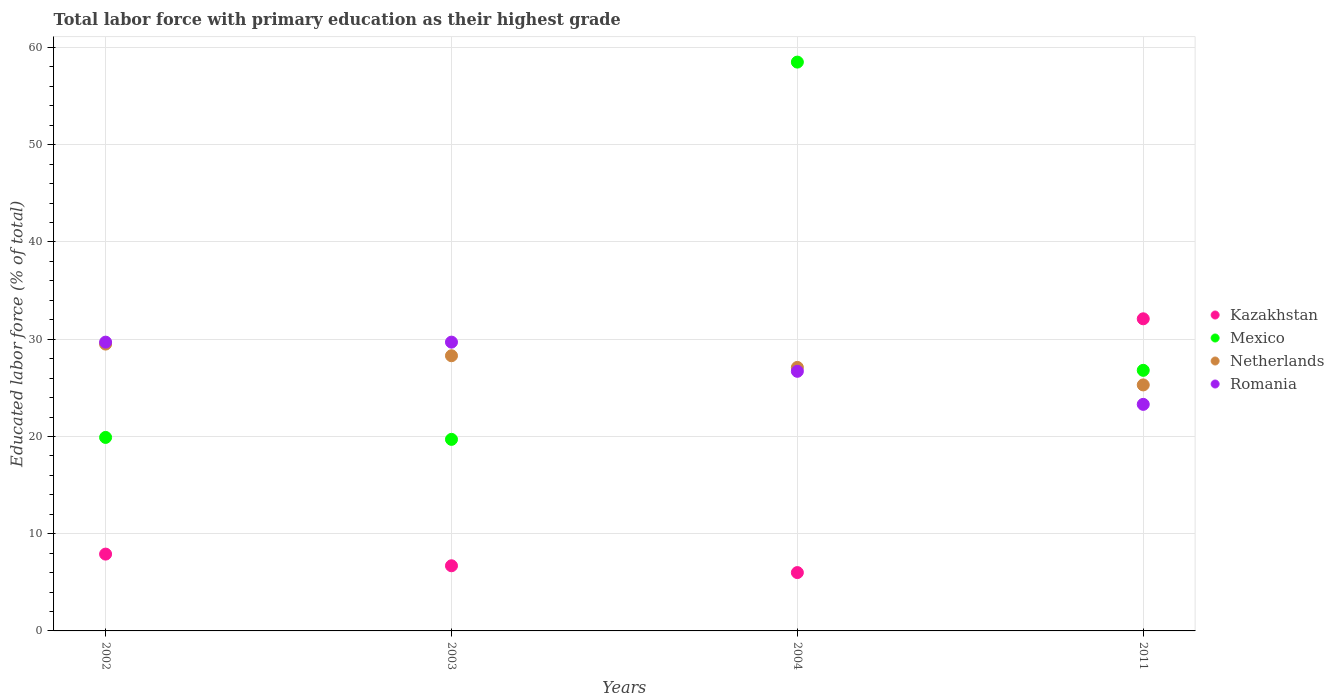How many different coloured dotlines are there?
Your response must be concise. 4. What is the percentage of total labor force with primary education in Romania in 2003?
Make the answer very short. 29.7. Across all years, what is the maximum percentage of total labor force with primary education in Netherlands?
Your answer should be compact. 29.5. Across all years, what is the minimum percentage of total labor force with primary education in Mexico?
Make the answer very short. 19.7. In which year was the percentage of total labor force with primary education in Romania maximum?
Your response must be concise. 2002. What is the total percentage of total labor force with primary education in Romania in the graph?
Ensure brevity in your answer.  109.4. What is the difference between the percentage of total labor force with primary education in Romania in 2002 and that in 2011?
Offer a terse response. 6.4. What is the difference between the percentage of total labor force with primary education in Mexico in 2004 and the percentage of total labor force with primary education in Netherlands in 2003?
Provide a short and direct response. 30.2. What is the average percentage of total labor force with primary education in Mexico per year?
Your response must be concise. 31.22. In the year 2002, what is the difference between the percentage of total labor force with primary education in Netherlands and percentage of total labor force with primary education in Kazakhstan?
Give a very brief answer. 21.6. What is the ratio of the percentage of total labor force with primary education in Romania in 2002 to that in 2003?
Make the answer very short. 1. Is the percentage of total labor force with primary education in Romania in 2002 less than that in 2011?
Give a very brief answer. No. What is the difference between the highest and the second highest percentage of total labor force with primary education in Kazakhstan?
Your answer should be compact. 24.2. What is the difference between the highest and the lowest percentage of total labor force with primary education in Mexico?
Provide a succinct answer. 38.8. In how many years, is the percentage of total labor force with primary education in Mexico greater than the average percentage of total labor force with primary education in Mexico taken over all years?
Provide a succinct answer. 1. Is it the case that in every year, the sum of the percentage of total labor force with primary education in Netherlands and percentage of total labor force with primary education in Romania  is greater than the percentage of total labor force with primary education in Mexico?
Give a very brief answer. No. Is the percentage of total labor force with primary education in Kazakhstan strictly greater than the percentage of total labor force with primary education in Netherlands over the years?
Your answer should be compact. No. Is the percentage of total labor force with primary education in Romania strictly less than the percentage of total labor force with primary education in Mexico over the years?
Your answer should be compact. No. How many years are there in the graph?
Provide a short and direct response. 4. Are the values on the major ticks of Y-axis written in scientific E-notation?
Give a very brief answer. No. Does the graph contain any zero values?
Offer a terse response. No. How many legend labels are there?
Provide a succinct answer. 4. What is the title of the graph?
Your answer should be very brief. Total labor force with primary education as their highest grade. What is the label or title of the Y-axis?
Offer a terse response. Educated labor force (% of total). What is the Educated labor force (% of total) in Kazakhstan in 2002?
Offer a terse response. 7.9. What is the Educated labor force (% of total) in Mexico in 2002?
Give a very brief answer. 19.9. What is the Educated labor force (% of total) in Netherlands in 2002?
Give a very brief answer. 29.5. What is the Educated labor force (% of total) in Romania in 2002?
Give a very brief answer. 29.7. What is the Educated labor force (% of total) of Kazakhstan in 2003?
Give a very brief answer. 6.7. What is the Educated labor force (% of total) in Mexico in 2003?
Provide a short and direct response. 19.7. What is the Educated labor force (% of total) of Netherlands in 2003?
Make the answer very short. 28.3. What is the Educated labor force (% of total) of Romania in 2003?
Offer a very short reply. 29.7. What is the Educated labor force (% of total) in Kazakhstan in 2004?
Make the answer very short. 6. What is the Educated labor force (% of total) in Mexico in 2004?
Your answer should be compact. 58.5. What is the Educated labor force (% of total) of Netherlands in 2004?
Your answer should be very brief. 27.1. What is the Educated labor force (% of total) of Romania in 2004?
Make the answer very short. 26.7. What is the Educated labor force (% of total) of Kazakhstan in 2011?
Give a very brief answer. 32.1. What is the Educated labor force (% of total) in Mexico in 2011?
Give a very brief answer. 26.8. What is the Educated labor force (% of total) of Netherlands in 2011?
Offer a terse response. 25.3. What is the Educated labor force (% of total) in Romania in 2011?
Provide a short and direct response. 23.3. Across all years, what is the maximum Educated labor force (% of total) of Kazakhstan?
Make the answer very short. 32.1. Across all years, what is the maximum Educated labor force (% of total) in Mexico?
Your answer should be compact. 58.5. Across all years, what is the maximum Educated labor force (% of total) in Netherlands?
Keep it short and to the point. 29.5. Across all years, what is the maximum Educated labor force (% of total) in Romania?
Offer a very short reply. 29.7. Across all years, what is the minimum Educated labor force (% of total) in Mexico?
Keep it short and to the point. 19.7. Across all years, what is the minimum Educated labor force (% of total) of Netherlands?
Keep it short and to the point. 25.3. Across all years, what is the minimum Educated labor force (% of total) in Romania?
Your answer should be very brief. 23.3. What is the total Educated labor force (% of total) of Kazakhstan in the graph?
Offer a very short reply. 52.7. What is the total Educated labor force (% of total) in Mexico in the graph?
Give a very brief answer. 124.9. What is the total Educated labor force (% of total) of Netherlands in the graph?
Provide a short and direct response. 110.2. What is the total Educated labor force (% of total) of Romania in the graph?
Offer a terse response. 109.4. What is the difference between the Educated labor force (% of total) of Kazakhstan in 2002 and that in 2003?
Provide a short and direct response. 1.2. What is the difference between the Educated labor force (% of total) of Mexico in 2002 and that in 2004?
Your answer should be compact. -38.6. What is the difference between the Educated labor force (% of total) of Netherlands in 2002 and that in 2004?
Your response must be concise. 2.4. What is the difference between the Educated labor force (% of total) in Kazakhstan in 2002 and that in 2011?
Offer a terse response. -24.2. What is the difference between the Educated labor force (% of total) in Netherlands in 2002 and that in 2011?
Keep it short and to the point. 4.2. What is the difference between the Educated labor force (% of total) in Romania in 2002 and that in 2011?
Keep it short and to the point. 6.4. What is the difference between the Educated labor force (% of total) in Kazakhstan in 2003 and that in 2004?
Keep it short and to the point. 0.7. What is the difference between the Educated labor force (% of total) in Mexico in 2003 and that in 2004?
Your answer should be very brief. -38.8. What is the difference between the Educated labor force (% of total) in Kazakhstan in 2003 and that in 2011?
Keep it short and to the point. -25.4. What is the difference between the Educated labor force (% of total) in Kazakhstan in 2004 and that in 2011?
Provide a short and direct response. -26.1. What is the difference between the Educated labor force (% of total) of Mexico in 2004 and that in 2011?
Provide a short and direct response. 31.7. What is the difference between the Educated labor force (% of total) of Netherlands in 2004 and that in 2011?
Your answer should be compact. 1.8. What is the difference between the Educated labor force (% of total) of Kazakhstan in 2002 and the Educated labor force (% of total) of Mexico in 2003?
Your answer should be compact. -11.8. What is the difference between the Educated labor force (% of total) in Kazakhstan in 2002 and the Educated labor force (% of total) in Netherlands in 2003?
Offer a very short reply. -20.4. What is the difference between the Educated labor force (% of total) in Kazakhstan in 2002 and the Educated labor force (% of total) in Romania in 2003?
Ensure brevity in your answer.  -21.8. What is the difference between the Educated labor force (% of total) in Mexico in 2002 and the Educated labor force (% of total) in Netherlands in 2003?
Your answer should be very brief. -8.4. What is the difference between the Educated labor force (% of total) in Netherlands in 2002 and the Educated labor force (% of total) in Romania in 2003?
Your answer should be very brief. -0.2. What is the difference between the Educated labor force (% of total) of Kazakhstan in 2002 and the Educated labor force (% of total) of Mexico in 2004?
Give a very brief answer. -50.6. What is the difference between the Educated labor force (% of total) in Kazakhstan in 2002 and the Educated labor force (% of total) in Netherlands in 2004?
Your answer should be compact. -19.2. What is the difference between the Educated labor force (% of total) of Kazakhstan in 2002 and the Educated labor force (% of total) of Romania in 2004?
Keep it short and to the point. -18.8. What is the difference between the Educated labor force (% of total) in Netherlands in 2002 and the Educated labor force (% of total) in Romania in 2004?
Your answer should be compact. 2.8. What is the difference between the Educated labor force (% of total) of Kazakhstan in 2002 and the Educated labor force (% of total) of Mexico in 2011?
Provide a short and direct response. -18.9. What is the difference between the Educated labor force (% of total) in Kazakhstan in 2002 and the Educated labor force (% of total) in Netherlands in 2011?
Give a very brief answer. -17.4. What is the difference between the Educated labor force (% of total) of Kazakhstan in 2002 and the Educated labor force (% of total) of Romania in 2011?
Keep it short and to the point. -15.4. What is the difference between the Educated labor force (% of total) in Mexico in 2002 and the Educated labor force (% of total) in Netherlands in 2011?
Ensure brevity in your answer.  -5.4. What is the difference between the Educated labor force (% of total) of Kazakhstan in 2003 and the Educated labor force (% of total) of Mexico in 2004?
Make the answer very short. -51.8. What is the difference between the Educated labor force (% of total) in Kazakhstan in 2003 and the Educated labor force (% of total) in Netherlands in 2004?
Make the answer very short. -20.4. What is the difference between the Educated labor force (% of total) of Mexico in 2003 and the Educated labor force (% of total) of Netherlands in 2004?
Provide a succinct answer. -7.4. What is the difference between the Educated labor force (% of total) of Mexico in 2003 and the Educated labor force (% of total) of Romania in 2004?
Make the answer very short. -7. What is the difference between the Educated labor force (% of total) of Kazakhstan in 2003 and the Educated labor force (% of total) of Mexico in 2011?
Give a very brief answer. -20.1. What is the difference between the Educated labor force (% of total) of Kazakhstan in 2003 and the Educated labor force (% of total) of Netherlands in 2011?
Give a very brief answer. -18.6. What is the difference between the Educated labor force (% of total) in Kazakhstan in 2003 and the Educated labor force (% of total) in Romania in 2011?
Keep it short and to the point. -16.6. What is the difference between the Educated labor force (% of total) in Mexico in 2003 and the Educated labor force (% of total) in Netherlands in 2011?
Give a very brief answer. -5.6. What is the difference between the Educated labor force (% of total) in Kazakhstan in 2004 and the Educated labor force (% of total) in Mexico in 2011?
Keep it short and to the point. -20.8. What is the difference between the Educated labor force (% of total) in Kazakhstan in 2004 and the Educated labor force (% of total) in Netherlands in 2011?
Make the answer very short. -19.3. What is the difference between the Educated labor force (% of total) in Kazakhstan in 2004 and the Educated labor force (% of total) in Romania in 2011?
Keep it short and to the point. -17.3. What is the difference between the Educated labor force (% of total) in Mexico in 2004 and the Educated labor force (% of total) in Netherlands in 2011?
Give a very brief answer. 33.2. What is the difference between the Educated labor force (% of total) of Mexico in 2004 and the Educated labor force (% of total) of Romania in 2011?
Provide a short and direct response. 35.2. What is the average Educated labor force (% of total) in Kazakhstan per year?
Keep it short and to the point. 13.18. What is the average Educated labor force (% of total) in Mexico per year?
Provide a short and direct response. 31.23. What is the average Educated labor force (% of total) in Netherlands per year?
Give a very brief answer. 27.55. What is the average Educated labor force (% of total) in Romania per year?
Provide a short and direct response. 27.35. In the year 2002, what is the difference between the Educated labor force (% of total) of Kazakhstan and Educated labor force (% of total) of Mexico?
Your answer should be very brief. -12. In the year 2002, what is the difference between the Educated labor force (% of total) in Kazakhstan and Educated labor force (% of total) in Netherlands?
Offer a terse response. -21.6. In the year 2002, what is the difference between the Educated labor force (% of total) of Kazakhstan and Educated labor force (% of total) of Romania?
Your answer should be very brief. -21.8. In the year 2002, what is the difference between the Educated labor force (% of total) in Mexico and Educated labor force (% of total) in Netherlands?
Your response must be concise. -9.6. In the year 2002, what is the difference between the Educated labor force (% of total) in Mexico and Educated labor force (% of total) in Romania?
Make the answer very short. -9.8. In the year 2002, what is the difference between the Educated labor force (% of total) of Netherlands and Educated labor force (% of total) of Romania?
Your response must be concise. -0.2. In the year 2003, what is the difference between the Educated labor force (% of total) of Kazakhstan and Educated labor force (% of total) of Netherlands?
Keep it short and to the point. -21.6. In the year 2003, what is the difference between the Educated labor force (% of total) of Mexico and Educated labor force (% of total) of Netherlands?
Your answer should be compact. -8.6. In the year 2003, what is the difference between the Educated labor force (% of total) in Netherlands and Educated labor force (% of total) in Romania?
Keep it short and to the point. -1.4. In the year 2004, what is the difference between the Educated labor force (% of total) of Kazakhstan and Educated labor force (% of total) of Mexico?
Your answer should be very brief. -52.5. In the year 2004, what is the difference between the Educated labor force (% of total) of Kazakhstan and Educated labor force (% of total) of Netherlands?
Provide a short and direct response. -21.1. In the year 2004, what is the difference between the Educated labor force (% of total) of Kazakhstan and Educated labor force (% of total) of Romania?
Ensure brevity in your answer.  -20.7. In the year 2004, what is the difference between the Educated labor force (% of total) of Mexico and Educated labor force (% of total) of Netherlands?
Provide a succinct answer. 31.4. In the year 2004, what is the difference between the Educated labor force (% of total) in Mexico and Educated labor force (% of total) in Romania?
Your answer should be very brief. 31.8. In the year 2011, what is the difference between the Educated labor force (% of total) in Kazakhstan and Educated labor force (% of total) in Netherlands?
Your answer should be compact. 6.8. In the year 2011, what is the difference between the Educated labor force (% of total) of Kazakhstan and Educated labor force (% of total) of Romania?
Make the answer very short. 8.8. In the year 2011, what is the difference between the Educated labor force (% of total) of Mexico and Educated labor force (% of total) of Romania?
Your answer should be compact. 3.5. What is the ratio of the Educated labor force (% of total) of Kazakhstan in 2002 to that in 2003?
Provide a succinct answer. 1.18. What is the ratio of the Educated labor force (% of total) of Mexico in 2002 to that in 2003?
Your answer should be very brief. 1.01. What is the ratio of the Educated labor force (% of total) in Netherlands in 2002 to that in 2003?
Keep it short and to the point. 1.04. What is the ratio of the Educated labor force (% of total) of Romania in 2002 to that in 2003?
Provide a succinct answer. 1. What is the ratio of the Educated labor force (% of total) in Kazakhstan in 2002 to that in 2004?
Your answer should be compact. 1.32. What is the ratio of the Educated labor force (% of total) of Mexico in 2002 to that in 2004?
Offer a very short reply. 0.34. What is the ratio of the Educated labor force (% of total) in Netherlands in 2002 to that in 2004?
Give a very brief answer. 1.09. What is the ratio of the Educated labor force (% of total) of Romania in 2002 to that in 2004?
Your response must be concise. 1.11. What is the ratio of the Educated labor force (% of total) of Kazakhstan in 2002 to that in 2011?
Your response must be concise. 0.25. What is the ratio of the Educated labor force (% of total) in Mexico in 2002 to that in 2011?
Make the answer very short. 0.74. What is the ratio of the Educated labor force (% of total) in Netherlands in 2002 to that in 2011?
Make the answer very short. 1.17. What is the ratio of the Educated labor force (% of total) of Romania in 2002 to that in 2011?
Provide a short and direct response. 1.27. What is the ratio of the Educated labor force (% of total) of Kazakhstan in 2003 to that in 2004?
Your answer should be compact. 1.12. What is the ratio of the Educated labor force (% of total) of Mexico in 2003 to that in 2004?
Provide a short and direct response. 0.34. What is the ratio of the Educated labor force (% of total) in Netherlands in 2003 to that in 2004?
Ensure brevity in your answer.  1.04. What is the ratio of the Educated labor force (% of total) in Romania in 2003 to that in 2004?
Your answer should be very brief. 1.11. What is the ratio of the Educated labor force (% of total) of Kazakhstan in 2003 to that in 2011?
Make the answer very short. 0.21. What is the ratio of the Educated labor force (% of total) in Mexico in 2003 to that in 2011?
Give a very brief answer. 0.74. What is the ratio of the Educated labor force (% of total) of Netherlands in 2003 to that in 2011?
Your response must be concise. 1.12. What is the ratio of the Educated labor force (% of total) in Romania in 2003 to that in 2011?
Offer a terse response. 1.27. What is the ratio of the Educated labor force (% of total) in Kazakhstan in 2004 to that in 2011?
Your answer should be compact. 0.19. What is the ratio of the Educated labor force (% of total) of Mexico in 2004 to that in 2011?
Your answer should be very brief. 2.18. What is the ratio of the Educated labor force (% of total) of Netherlands in 2004 to that in 2011?
Your response must be concise. 1.07. What is the ratio of the Educated labor force (% of total) in Romania in 2004 to that in 2011?
Make the answer very short. 1.15. What is the difference between the highest and the second highest Educated labor force (% of total) of Kazakhstan?
Keep it short and to the point. 24.2. What is the difference between the highest and the second highest Educated labor force (% of total) of Mexico?
Make the answer very short. 31.7. What is the difference between the highest and the second highest Educated labor force (% of total) of Netherlands?
Your answer should be very brief. 1.2. What is the difference between the highest and the lowest Educated labor force (% of total) in Kazakhstan?
Your answer should be very brief. 26.1. What is the difference between the highest and the lowest Educated labor force (% of total) in Mexico?
Your answer should be very brief. 38.8. 